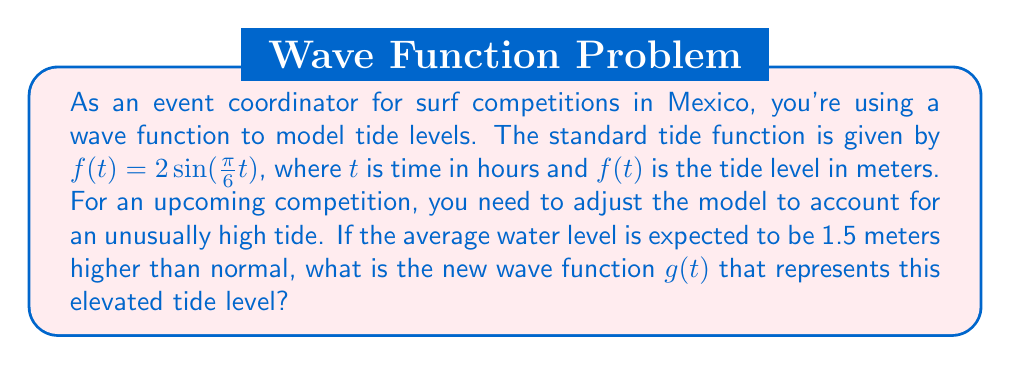Can you solve this math problem? To solve this problem, we need to apply a vertical shift to the original function. Here's how we do it step-by-step:

1) The original function is $f(t) = 2\sin(\frac{\pi}{6}t)$.

2) To shift a function vertically, we add or subtract a constant. In this case, we need to shift the function up by 1.5 meters.

3) The general form of a vertical shift is:
   $g(t) = f(t) + k$
   where $k$ is the amount of the shift (positive for up, negative for down).

4) In this case, $k = 1.5$ (shifting up by 1.5 meters).

5) Therefore, our new function $g(t)$ is:
   $g(t) = f(t) + 1.5$

6) Substituting the original function:
   $g(t) = 2\sin(\frac{\pi}{6}t) + 1.5$

This new function $g(t)$ represents the tide level with the 1.5-meter increase in average water level.
Answer: $g(t) = 2\sin(\frac{\pi}{6}t) + 1.5$ 